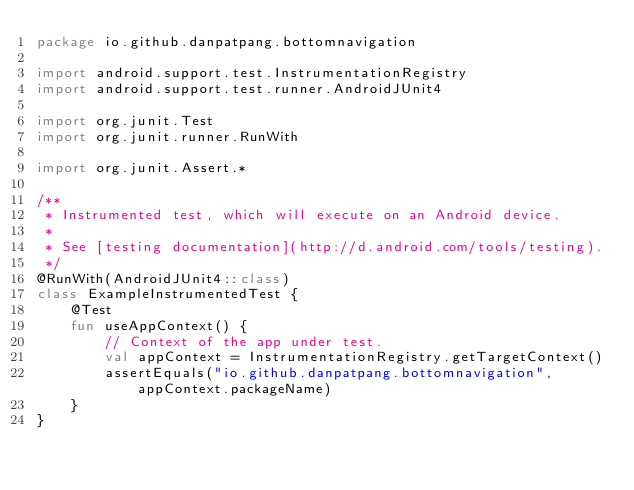<code> <loc_0><loc_0><loc_500><loc_500><_Kotlin_>package io.github.danpatpang.bottomnavigation

import android.support.test.InstrumentationRegistry
import android.support.test.runner.AndroidJUnit4

import org.junit.Test
import org.junit.runner.RunWith

import org.junit.Assert.*

/**
 * Instrumented test, which will execute on an Android device.
 *
 * See [testing documentation](http://d.android.com/tools/testing).
 */
@RunWith(AndroidJUnit4::class)
class ExampleInstrumentedTest {
    @Test
    fun useAppContext() {
        // Context of the app under test.
        val appContext = InstrumentationRegistry.getTargetContext()
        assertEquals("io.github.danpatpang.bottomnavigation", appContext.packageName)
    }
}
</code> 